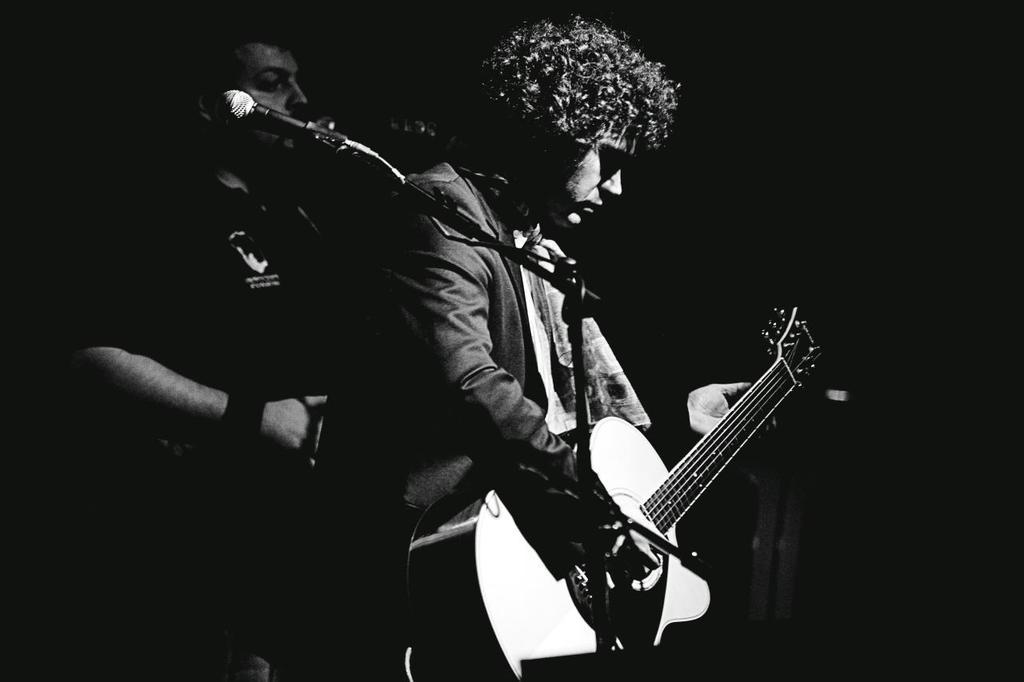What is the overall color scheme of the image? The background of the image is dark. How many people are in the picture? There are two men in the picture. What object is present in the image that is commonly used for amplifying sound? There is a microphone in the image. What is the man in the front portion of the image doing? One man is standing and playing a guitar in the front portion of the image. What type of quilt is being used as a prop in the image? There is no quilt present in the image. What historical event is being commemorated in the image? The image does not depict any specific historical event. 